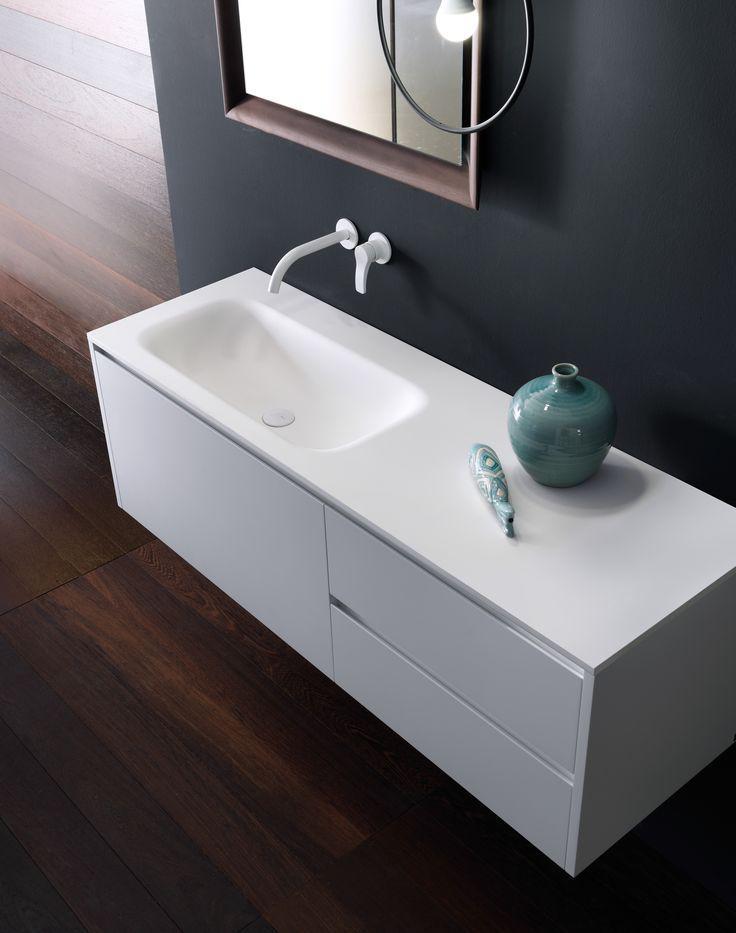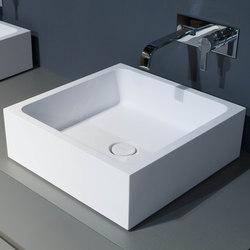The first image is the image on the left, the second image is the image on the right. For the images shown, is this caption "Each image shows a white counter with a single undivided rectangular sink carved into it, and at least one image features a row of six spouts above the basin." true? Answer yes or no. No. The first image is the image on the left, the second image is the image on the right. Examine the images to the left and right. Is the description "In at least one image there is at least one floating white sink sitting on top of a grey block." accurate? Answer yes or no. Yes. 